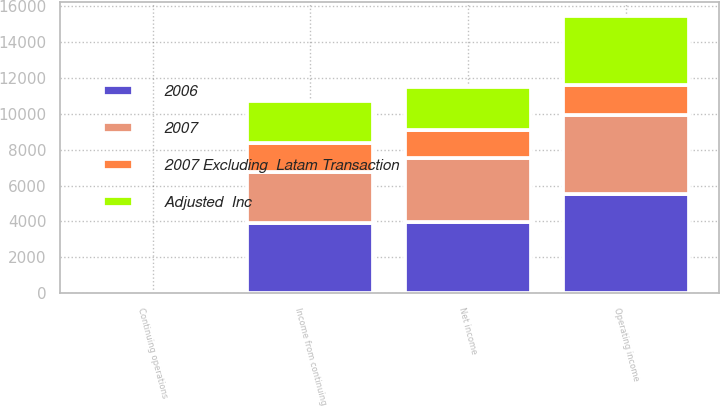Convert chart to OTSL. <chart><loc_0><loc_0><loc_500><loc_500><stacked_bar_chart><ecel><fcel>Operating income<fcel>Income from continuing<fcel>Net income<fcel>Continuing operations<nl><fcel>Adjusted  Inc<fcel>3879<fcel>2335<fcel>2395<fcel>1.93<nl><fcel>2007 Excluding  Latam Transaction<fcel>1641<fcel>1579<fcel>1579<fcel>1.3<nl><fcel>2006<fcel>5520<fcel>3914<fcel>3974<fcel>3.23<nl><fcel>2007<fcel>4433<fcel>2866<fcel>3544<fcel>2.29<nl></chart> 